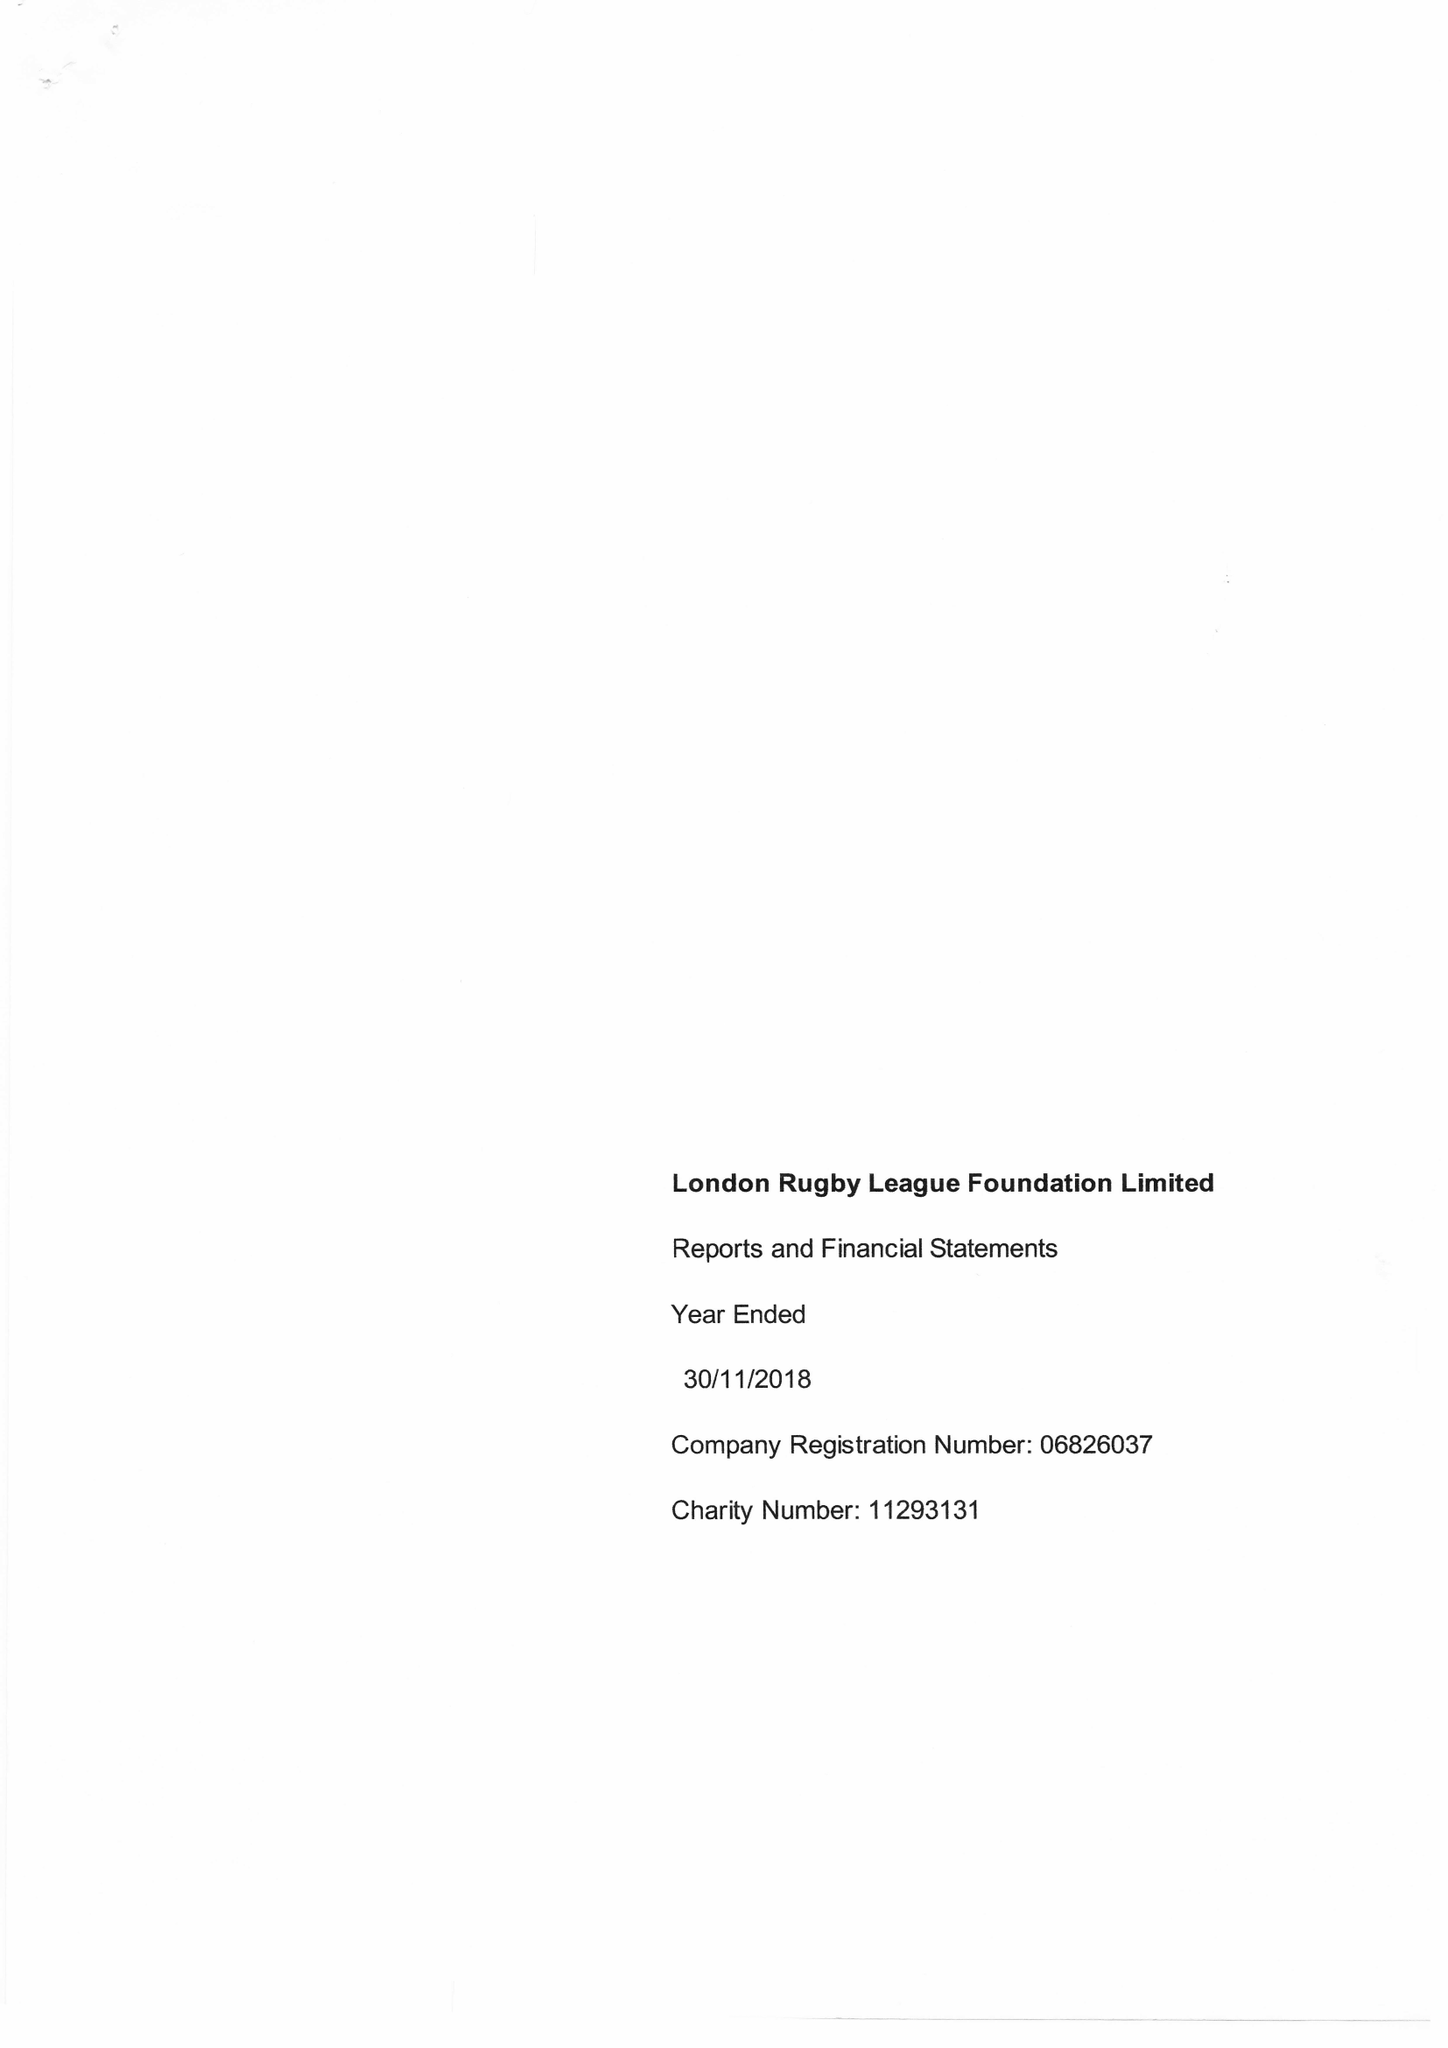What is the value for the address__post_town?
Answer the question using a single word or phrase. LONDON 